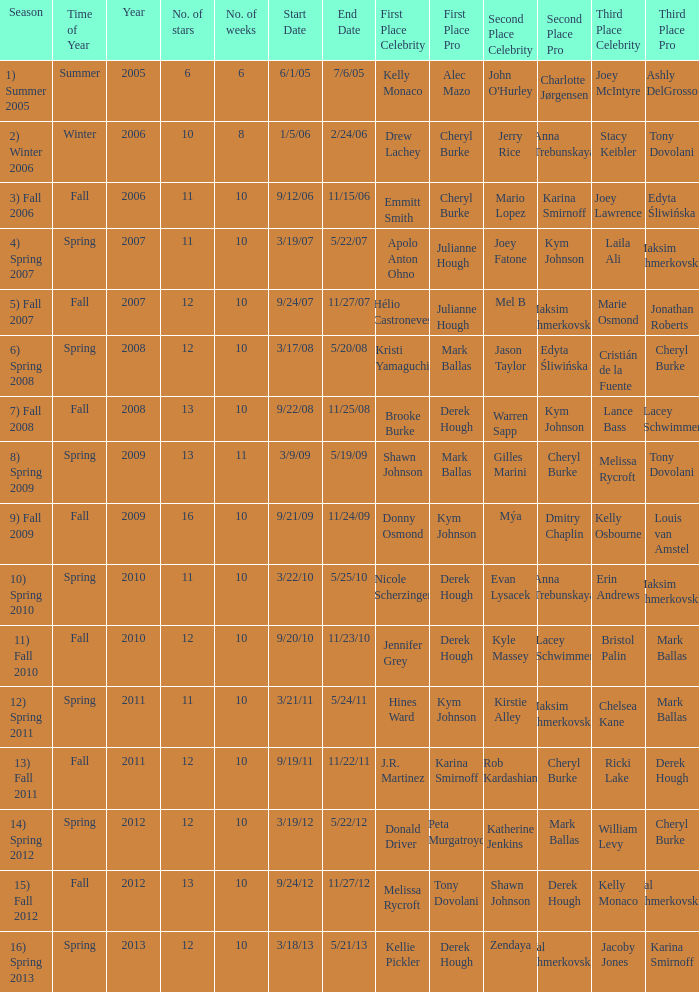Parse the table in full. {'header': ['Season', 'Time of Year', 'Year', 'No. of stars', 'No. of weeks', 'Start Date', 'End Date', 'First Place Celebrity', 'First Place Pro', 'Second Place Celebrity', 'Second Place Pro', 'Third Place Celebrity', 'Third Place Pro'], 'rows': [['1) Summer 2005', 'Summer', '2005', '6', '6', '6/1/05', '7/6/05', 'Kelly Monaco', 'Alec Mazo', "John O'Hurley", 'Charlotte Jørgensen', 'Joey McIntyre', 'Ashly DelGrosso'], ['2) Winter 2006', 'Winter', '2006', '10', '8', '1/5/06', '2/24/06', 'Drew Lachey', 'Cheryl Burke', 'Jerry Rice', 'Anna Trebunskaya', 'Stacy Keibler', 'Tony Dovolani'], ['3) Fall 2006', 'Fall', '2006', '11', '10', '9/12/06', '11/15/06', 'Emmitt Smith', 'Cheryl Burke', 'Mario Lopez', 'Karina Smirnoff', 'Joey Lawrence', 'Edyta Śliwińska'], ['4) Spring 2007', 'Spring', '2007', '11', '10', '3/19/07', '5/22/07', 'Apolo Anton Ohno', 'Julianne Hough', 'Joey Fatone', 'Kym Johnson', 'Laila Ali', 'Maksim Chmerkovskiy'], ['5) Fall 2007', 'Fall', '2007', '12', '10', '9/24/07', '11/27/07', 'Hélio Castroneves', 'Julianne Hough', 'Mel B', 'Maksim Chmerkovskiy', 'Marie Osmond', 'Jonathan Roberts'], ['6) Spring 2008', 'Spring', '2008', '12', '10', '3/17/08', '5/20/08', 'Kristi Yamaguchi', 'Mark Ballas', 'Jason Taylor', 'Edyta Śliwińska', 'Cristián de la Fuente', 'Cheryl Burke'], ['7) Fall 2008', 'Fall', '2008', '13', '10', '9/22/08', '11/25/08', 'Brooke Burke', 'Derek Hough', 'Warren Sapp', 'Kym Johnson', 'Lance Bass', 'Lacey Schwimmer'], ['8) Spring 2009', 'Spring', '2009', '13', '11', '3/9/09', '5/19/09', 'Shawn Johnson', 'Mark Ballas', 'Gilles Marini', 'Cheryl Burke', 'Melissa Rycroft', 'Tony Dovolani'], ['9) Fall 2009', 'Fall', '2009', '16', '10', '9/21/09', '11/24/09', 'Donny Osmond', 'Kym Johnson', 'Mýa', 'Dmitry Chaplin', 'Kelly Osbourne', 'Louis van Amstel'], ['10) Spring 2010', 'Spring', '2010', '11', '10', '3/22/10', '5/25/10', 'Nicole Scherzinger', 'Derek Hough', 'Evan Lysacek', 'Anna Trebunskaya', 'Erin Andrews', 'Maksim Chmerkovskiy'], ['11) Fall 2010', 'Fall', '2010', '12', '10', '9/20/10', '11/23/10', 'Jennifer Grey', 'Derek Hough', 'Kyle Massey', 'Lacey Schwimmer', 'Bristol Palin', 'Mark Ballas'], ['12) Spring 2011', 'Spring', '2011', '11', '10', '3/21/11', '5/24/11', 'Hines Ward', 'Kym Johnson', 'Kirstie Alley', 'Maksim Chmerkovskiy', 'Chelsea Kane', 'Mark Ballas'], ['13) Fall 2011', 'Fall', '2011', '12', '10', '9/19/11', '11/22/11', 'J.R. Martinez', 'Karina Smirnoff', 'Rob Kardashian', 'Cheryl Burke', 'Ricki Lake', 'Derek Hough'], ['14) Spring 2012', 'Spring', '2012', '12', '10', '3/19/12', '5/22/12', 'Donald Driver', 'Peta Murgatroyd', 'Katherine Jenkins', 'Mark Ballas', 'William Levy', 'Cheryl Burke'], ['15) Fall 2012', 'Fall', '2012', '13', '10', '9/24/12', '11/27/12', 'Melissa Rycroft', 'Tony Dovolani', 'Shawn Johnson', 'Derek Hough', 'Kelly Monaco', 'Val Chmerkovskiy'], ['16) Spring 2013', 'Spring', '2013', '12', '10', '3/18/13', '5/21/13', 'Kellie Pickler', 'Derek Hough', 'Zendaya', 'Val Chmerkovskiy', 'Jacoby Jones', 'Karina Smirnoff']]} Who took first place in week 6? 1.0. 